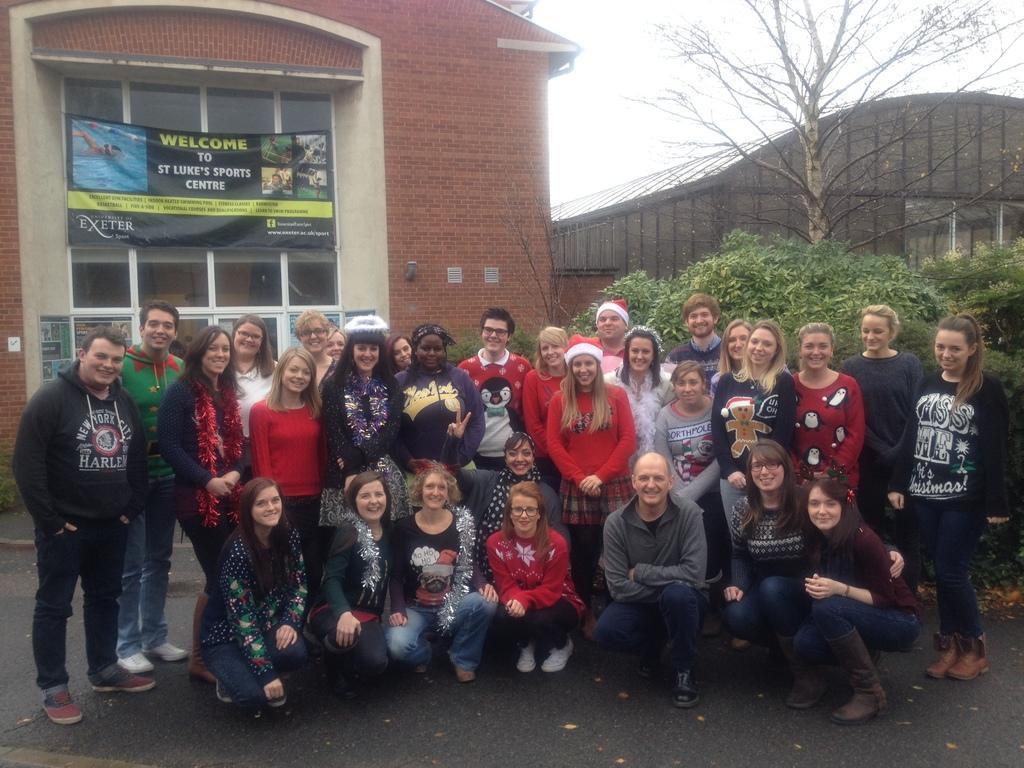In one or two sentences, can you explain what this image depicts? There are people in the center of the image and there are buildings, posters, greenery and sky in the background area. 